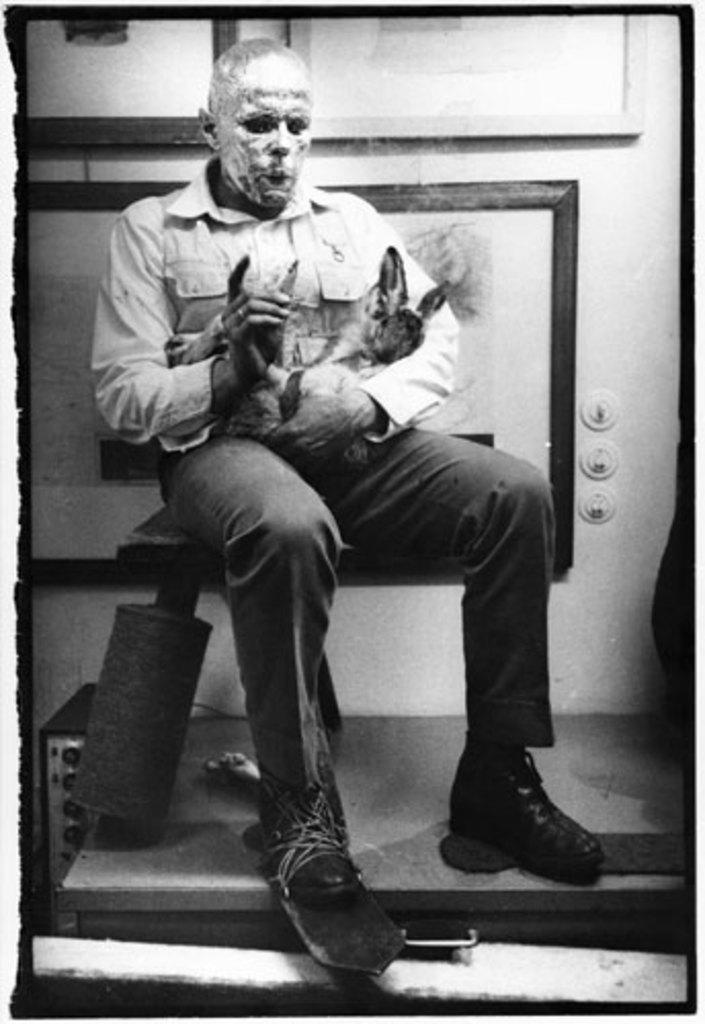What is the main subject of the picture? The main subject of the picture is a person sitting in the middle. What is the person holding in the image? The person is holding an animal. What can be seen in the background of the picture? There are frames in the background of the image. What is the color of the border around the picture? The picture has a white border. What type of screw can be seen in the person's hand in the image? There is no screw present in the person's hand or in the image. Is the person sitting in an office in the image? The image does not provide any information about the location or setting, so it cannot be determined if the person is sitting in an office. 